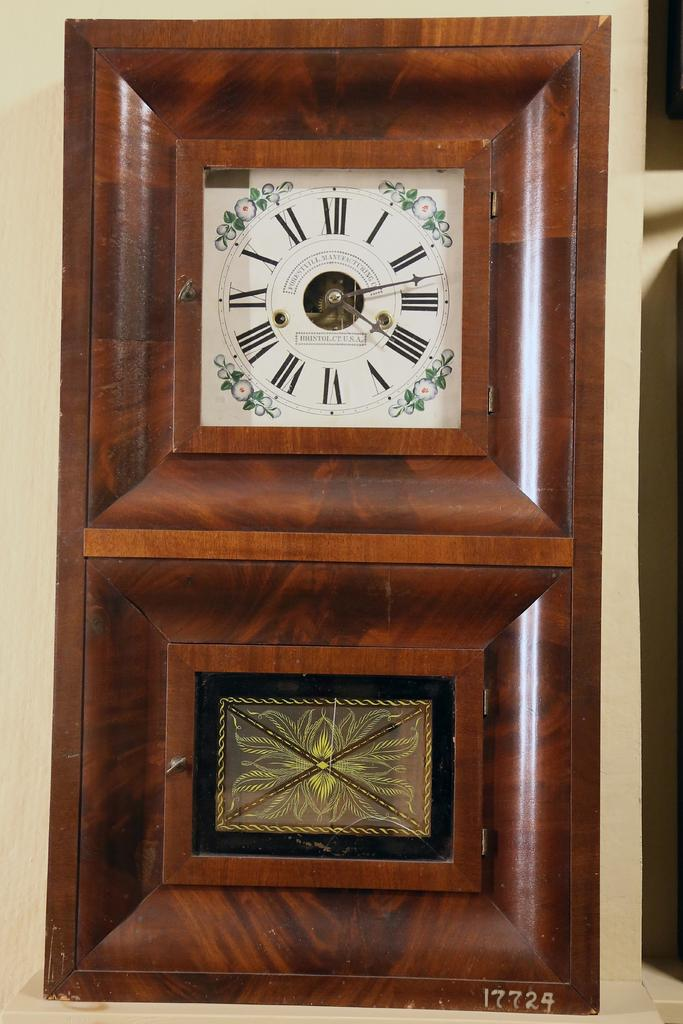<image>
Provide a brief description of the given image. many roman numerals that are on a clock 